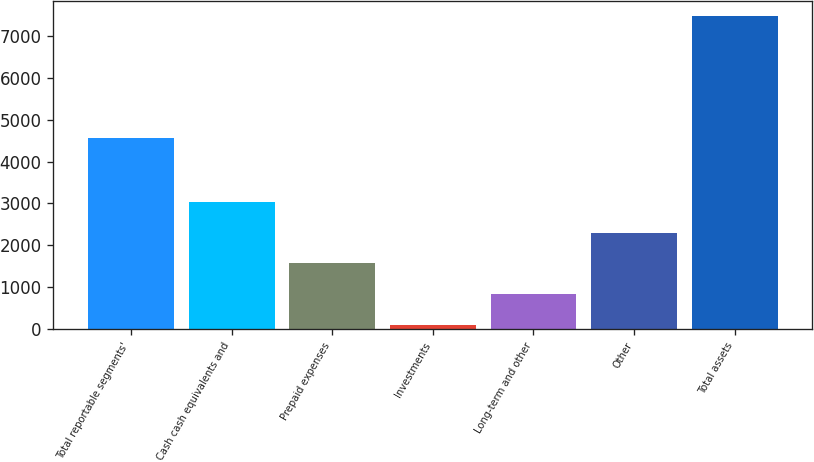Convert chart. <chart><loc_0><loc_0><loc_500><loc_500><bar_chart><fcel>Total reportable segments'<fcel>Cash cash equivalents and<fcel>Prepaid expenses<fcel>Investments<fcel>Long-term and other<fcel>Other<fcel>Total assets<nl><fcel>4574<fcel>3043.2<fcel>1564.6<fcel>86<fcel>825.3<fcel>2303.9<fcel>7479<nl></chart> 